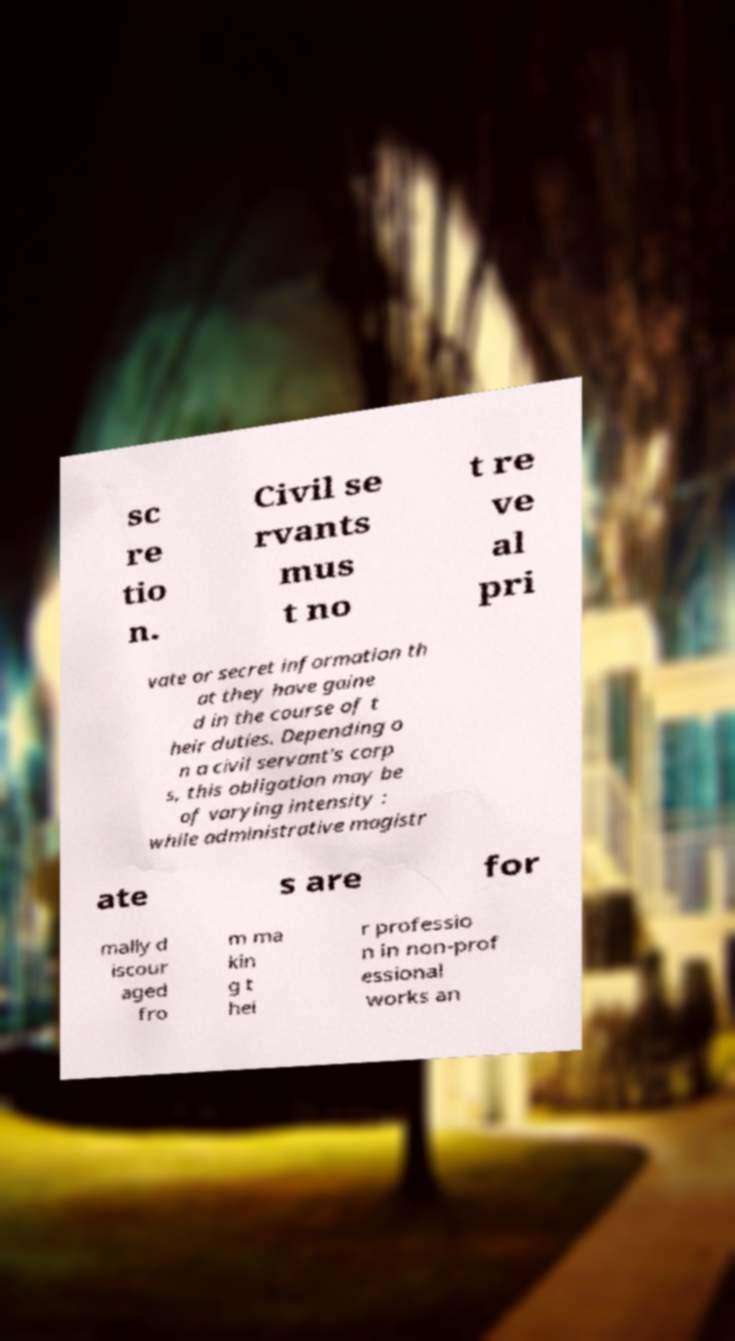Can you accurately transcribe the text from the provided image for me? sc re tio n. Civil se rvants mus t no t re ve al pri vate or secret information th at they have gaine d in the course of t heir duties. Depending o n a civil servant's corp s, this obligation may be of varying intensity : while administrative magistr ate s are for mally d iscour aged fro m ma kin g t hei r professio n in non-prof essional works an 